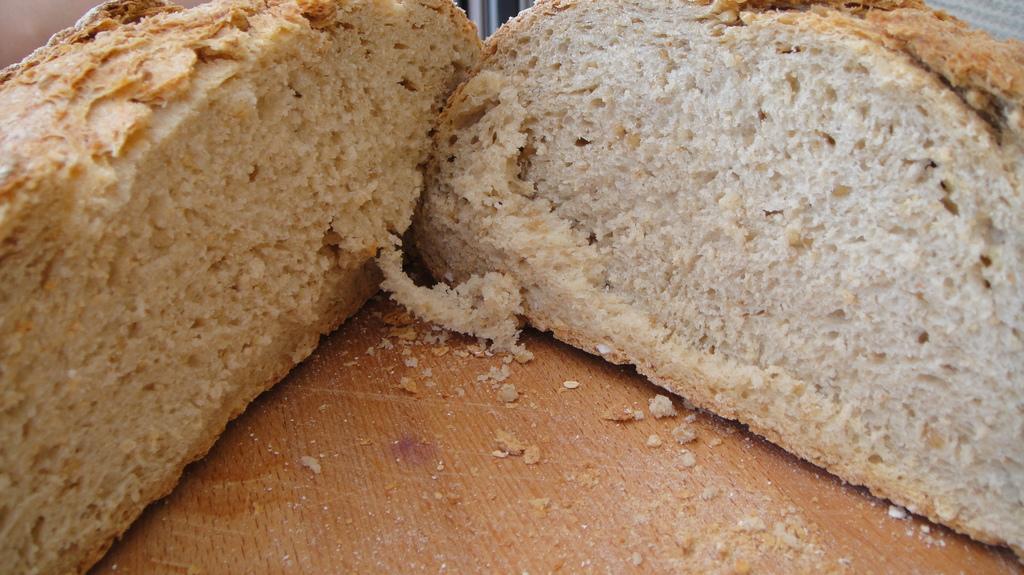Could you give a brief overview of what you see in this image? In this picture I can see 2 pieces of bread and I can see the brown color surface. 